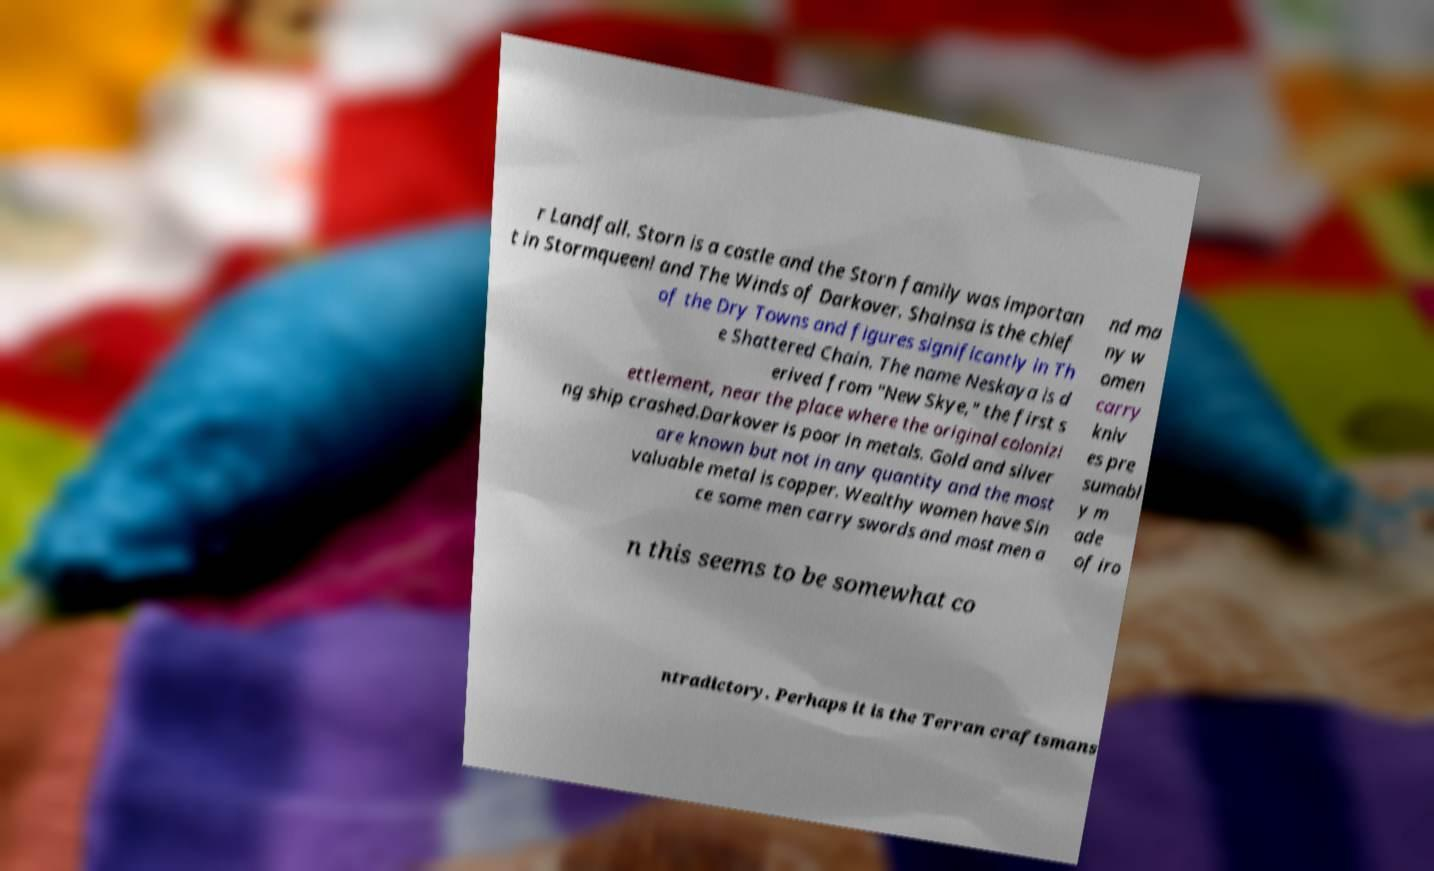Please read and relay the text visible in this image. What does it say? r Landfall. Storn is a castle and the Storn family was importan t in Stormqueen! and The Winds of Darkover. Shainsa is the chief of the Dry Towns and figures significantly in Th e Shattered Chain. The name Neskaya is d erived from "New Skye," the first s ettlement, near the place where the original colonizi ng ship crashed.Darkover is poor in metals. Gold and silver are known but not in any quantity and the most valuable metal is copper. Wealthy women have Sin ce some men carry swords and most men a nd ma ny w omen carry kniv es pre sumabl y m ade of iro n this seems to be somewhat co ntradictory. Perhaps it is the Terran craftsmans 